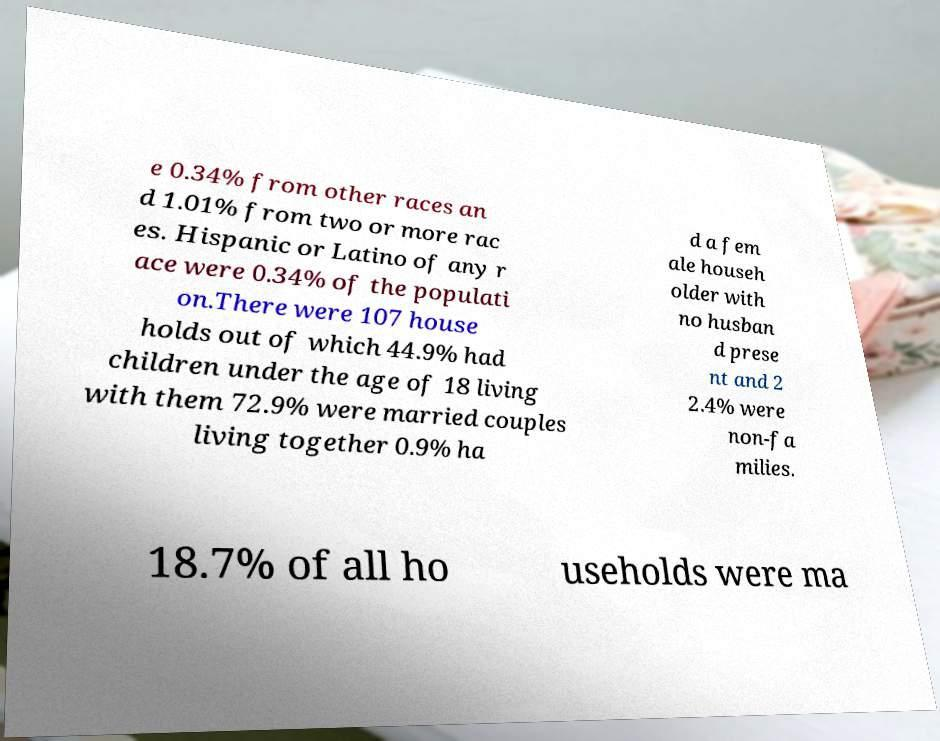Could you assist in decoding the text presented in this image and type it out clearly? e 0.34% from other races an d 1.01% from two or more rac es. Hispanic or Latino of any r ace were 0.34% of the populati on.There were 107 house holds out of which 44.9% had children under the age of 18 living with them 72.9% were married couples living together 0.9% ha d a fem ale househ older with no husban d prese nt and 2 2.4% were non-fa milies. 18.7% of all ho useholds were ma 